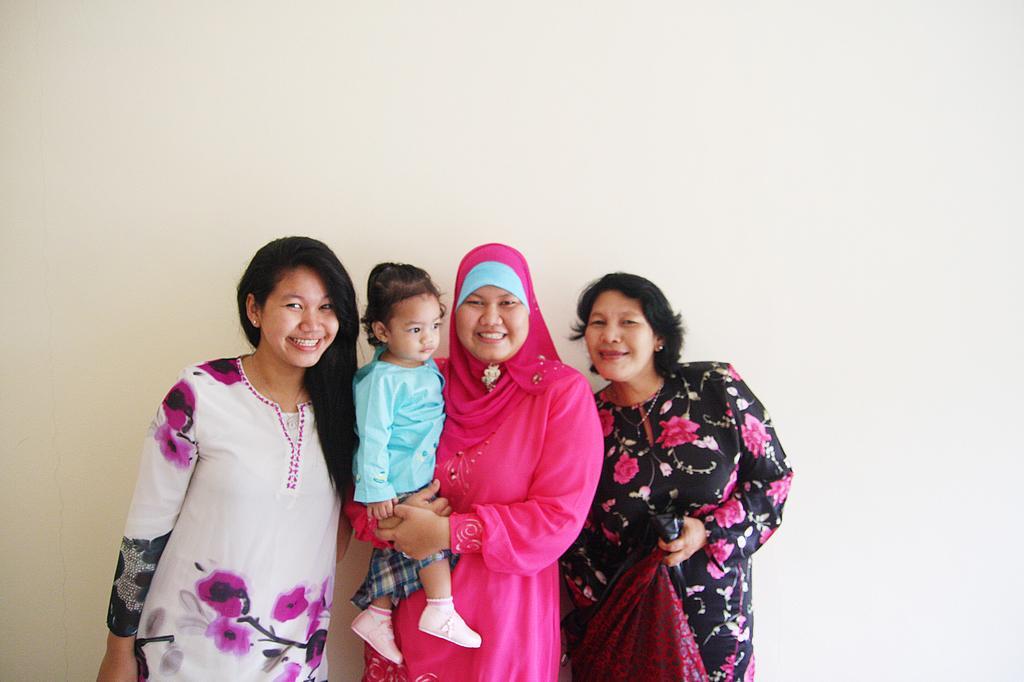Describe this image in one or two sentences. In the image there are three women standing in front of the wall and posing for the photo and among them the middle woman is holding a baby with her hands. 